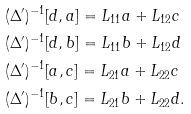Convert formula to latex. <formula><loc_0><loc_0><loc_500><loc_500>& ( \Delta ^ { \prime } ) ^ { - 1 } [ d , a ] = L _ { 1 1 } a + L _ { 1 2 } c \\ & ( \Delta ^ { \prime } ) ^ { - 1 } [ d , b ] = L _ { 1 1 } b + L _ { 1 2 } d \\ & ( \Delta ^ { \prime } ) ^ { - 1 } [ a , c ] = L _ { 2 1 } a + L _ { 2 2 } c \\ & ( \Delta ^ { \prime } ) ^ { - 1 } [ b , c ] = L _ { 2 1 } b + L _ { 2 2 } d .</formula> 